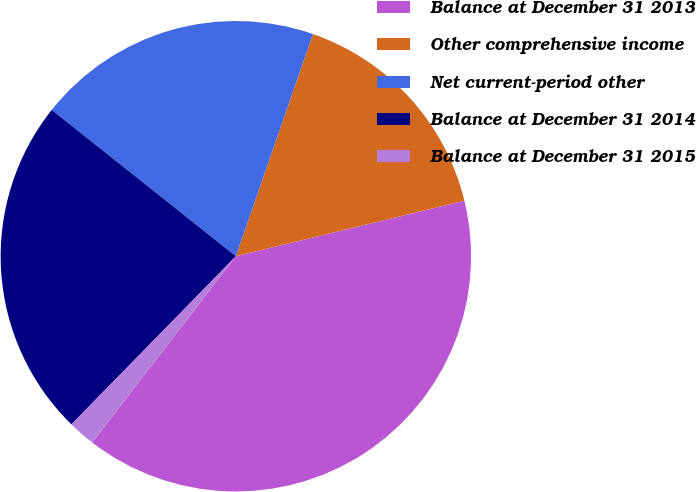Convert chart. <chart><loc_0><loc_0><loc_500><loc_500><pie_chart><fcel>Balance at December 31 2013<fcel>Other comprehensive income<fcel>Net current-period other<fcel>Balance at December 31 2014<fcel>Balance at December 31 2015<nl><fcel>39.25%<fcel>15.89%<fcel>19.63%<fcel>23.36%<fcel>1.87%<nl></chart> 